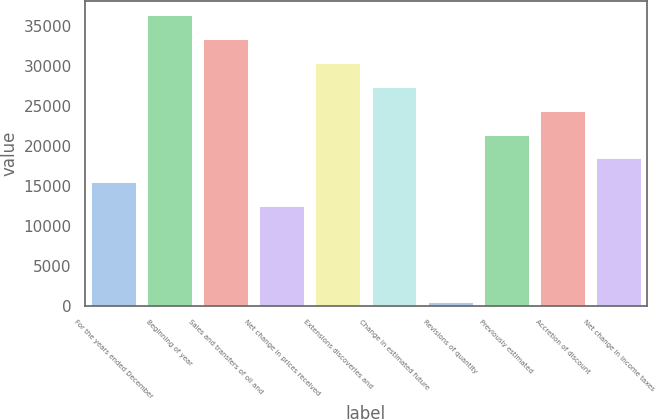Convert chart to OTSL. <chart><loc_0><loc_0><loc_500><loc_500><bar_chart><fcel>For the years ended December<fcel>Beginning of year<fcel>Sales and transfers of oil and<fcel>Net change in prices received<fcel>Extensions discoveries and<fcel>Change in estimated future<fcel>Revisions of quantity<fcel>Previously estimated<fcel>Accretion of discount<fcel>Net change in income taxes<nl><fcel>15443.5<fcel>36399.4<fcel>33405.7<fcel>12449.8<fcel>30412<fcel>27418.3<fcel>475<fcel>21430.9<fcel>24424.6<fcel>18437.2<nl></chart> 